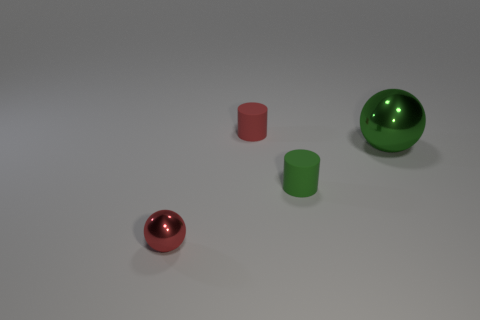What shape is the tiny thing that is on the left side of the green rubber cylinder and to the right of the small red shiny object?
Provide a succinct answer. Cylinder. There is a green matte object; how many red metallic balls are left of it?
Offer a terse response. 1. What number of other things are there of the same shape as the large green metal thing?
Ensure brevity in your answer.  1. Is the number of red matte cylinders less than the number of small purple objects?
Provide a short and direct response. No. What is the size of the thing that is right of the red rubber thing and behind the small green matte cylinder?
Offer a very short reply. Large. There is a ball that is to the left of the tiny matte cylinder that is right of the red object that is behind the red metal thing; what is its size?
Offer a terse response. Small. The red cylinder has what size?
Ensure brevity in your answer.  Small. Is there a object that is behind the tiny object to the left of the tiny cylinder behind the big green object?
Offer a very short reply. Yes. How many big objects are either red objects or yellow metallic things?
Your answer should be very brief. 0. Is there anything else of the same color as the small metallic object?
Ensure brevity in your answer.  Yes. 